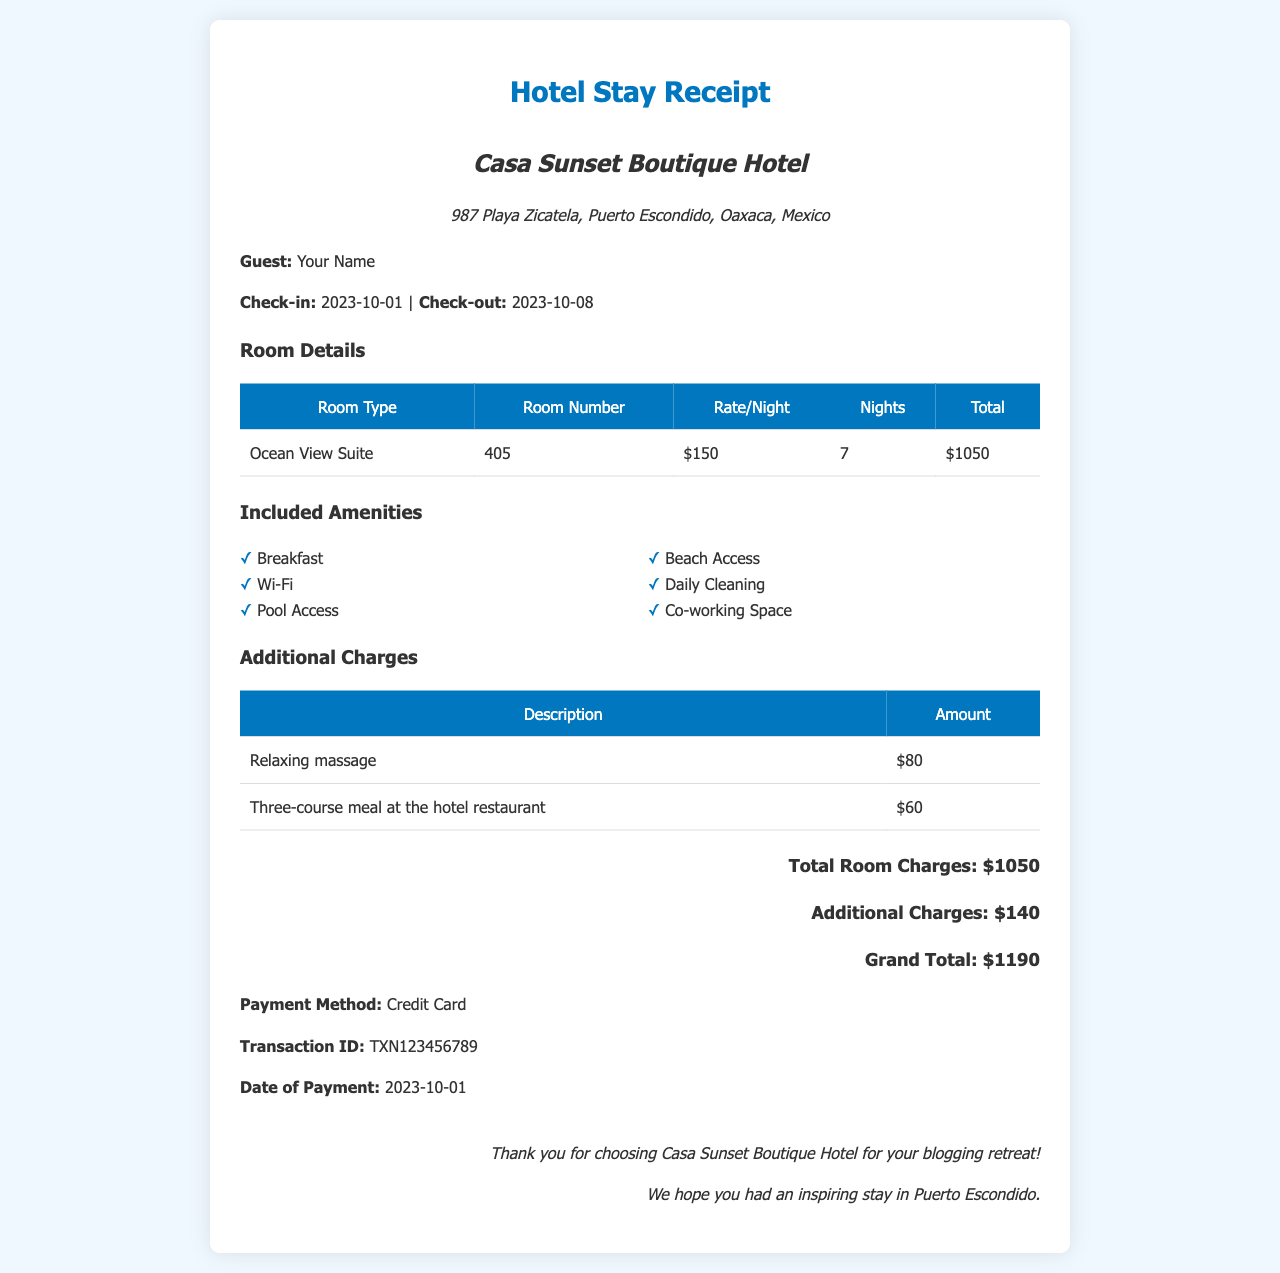What is the hotel name? The hotel name is displayed prominently at the top of the receipt, which identifies it as Casa Sunset Boutique Hotel.
Answer: Casa Sunset Boutique Hotel What is the total room charge? The total room charge is indicated in the document as part of the total summary above the grand total.
Answer: $1050 How many nights did the guest stay? The number of nights is listed in the room details section, indicating how long the guest occupied the room.
Answer: 7 What amenities are included with the stay? A list of amenities is provided under the included amenities section of the document, showing what guests receive during their stay.
Answer: Breakfast, Wi-Fi, Pool Access, Beach Access, Daily Cleaning, Co-working Space What room type did the guest stay in? The document specifies the type of room under the room details section, indicating the accommodation provided.
Answer: Ocean View Suite What is the grand total amount charged? The grand total is summarized at the end of the receipt, reflecting the overall cost of the stay and additional charges.
Answer: $1190 What date did the guest check in? The check-in date is specified in the guest information section of the receipt, alongside the check-out date.
Answer: 2023-10-01 What additional charge was for the relaxing massage? Additional charges are listed in a table, detailing extra expenses incurred during the stay.
Answer: $80 How did the guest pay for the stay? The payment method is noted at the bottom of the receipt, indicating how the guest completed their transaction.
Answer: Credit Card 